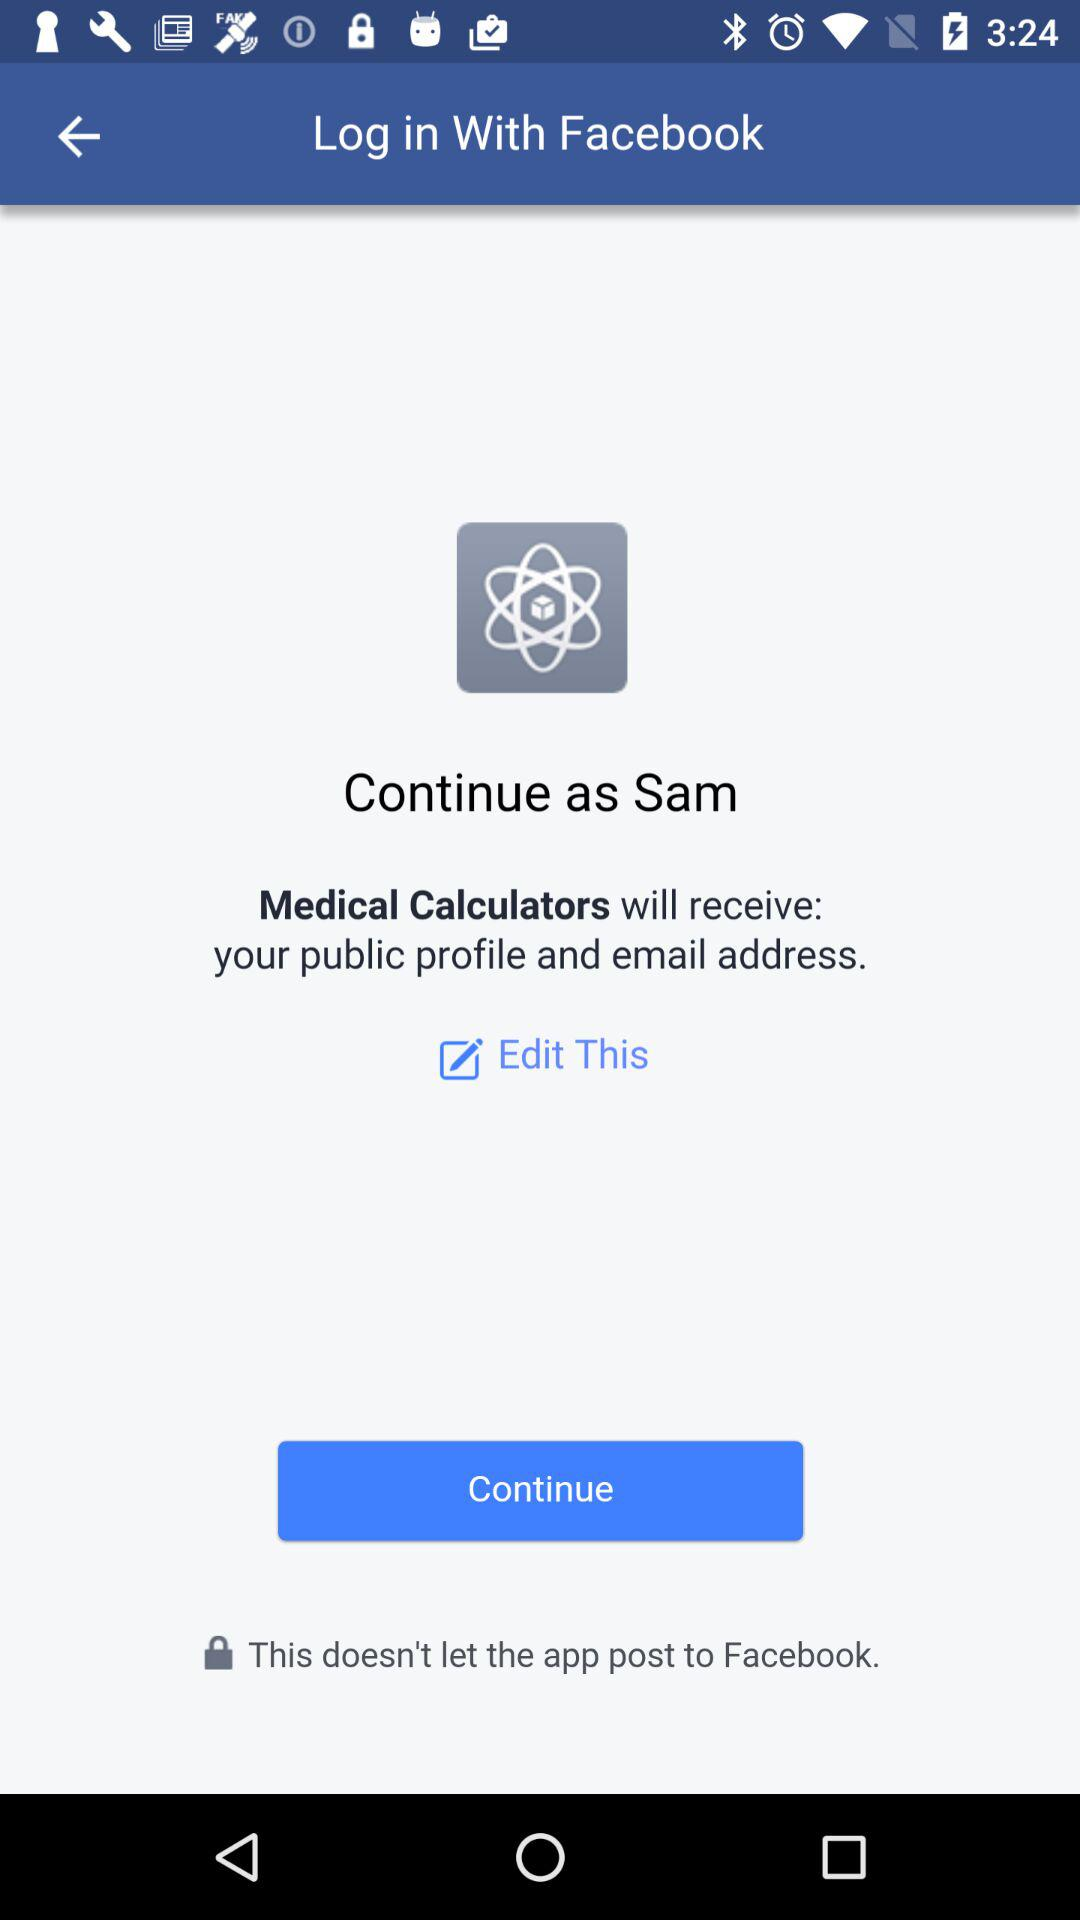What is the user name? The user name is Sam. 